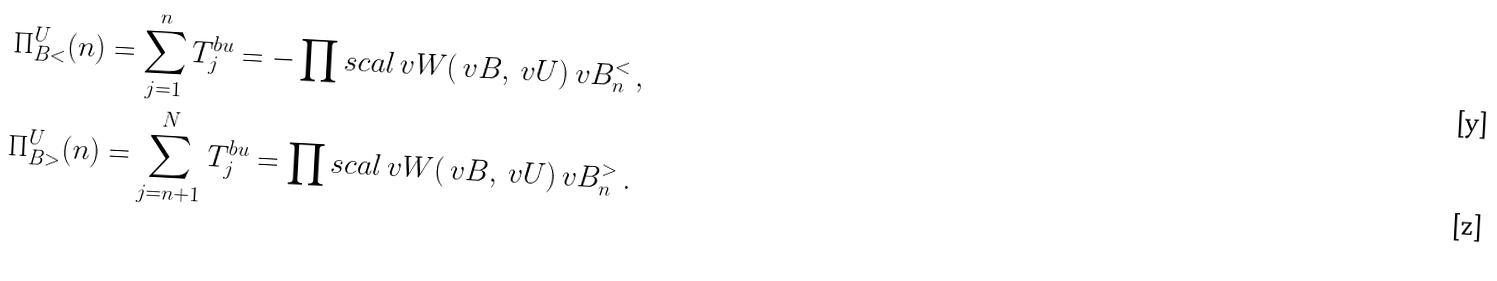<formula> <loc_0><loc_0><loc_500><loc_500>\Pi ^ { U } _ { B < } ( n ) & = \sum _ { j = 1 } ^ { n } T ^ { b u } _ { j } = - \prod s c a l { \ v W ( \ v B , \ v U ) } { \ v B ^ { < } _ { n } } \, , \\ \Pi ^ { U } _ { B > } ( n ) & = \sum _ { j = n + 1 } ^ { N } T ^ { b u } _ { j } = \prod s c a l { \ v W ( \ v B , \ v U ) } { \ v B ^ { > } _ { n } } \, .</formula> 